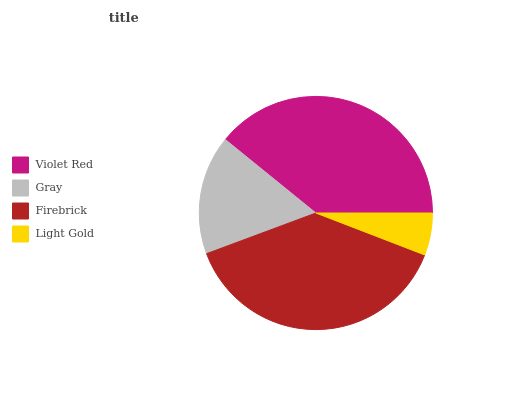Is Light Gold the minimum?
Answer yes or no. Yes. Is Violet Red the maximum?
Answer yes or no. Yes. Is Gray the minimum?
Answer yes or no. No. Is Gray the maximum?
Answer yes or no. No. Is Violet Red greater than Gray?
Answer yes or no. Yes. Is Gray less than Violet Red?
Answer yes or no. Yes. Is Gray greater than Violet Red?
Answer yes or no. No. Is Violet Red less than Gray?
Answer yes or no. No. Is Firebrick the high median?
Answer yes or no. Yes. Is Gray the low median?
Answer yes or no. Yes. Is Light Gold the high median?
Answer yes or no. No. Is Violet Red the low median?
Answer yes or no. No. 